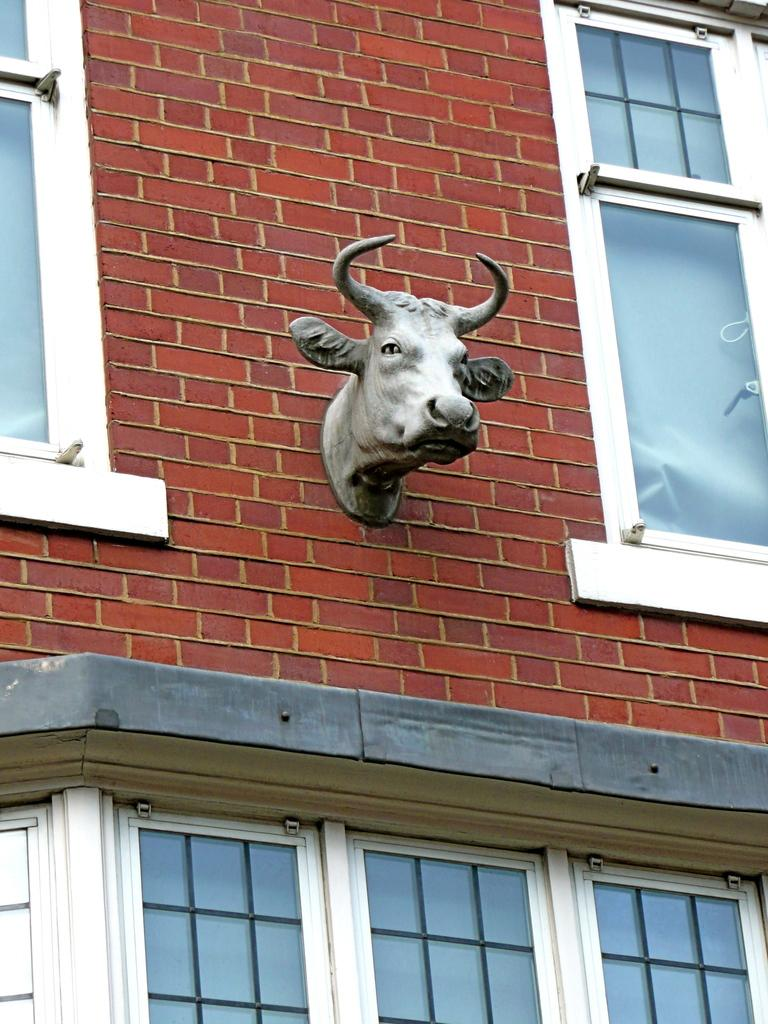What type of toy is in the image? There is a face toy of an animal in the image. How is the toy positioned in the image? The toy is attached to the wall. What can be seen near the toy in the image? There are windows beside and below the toy. What type of knee injury can be seen in the image? There is no knee injury present in the image; it features a face toy of an animal attached to the wall with windows nearby. 